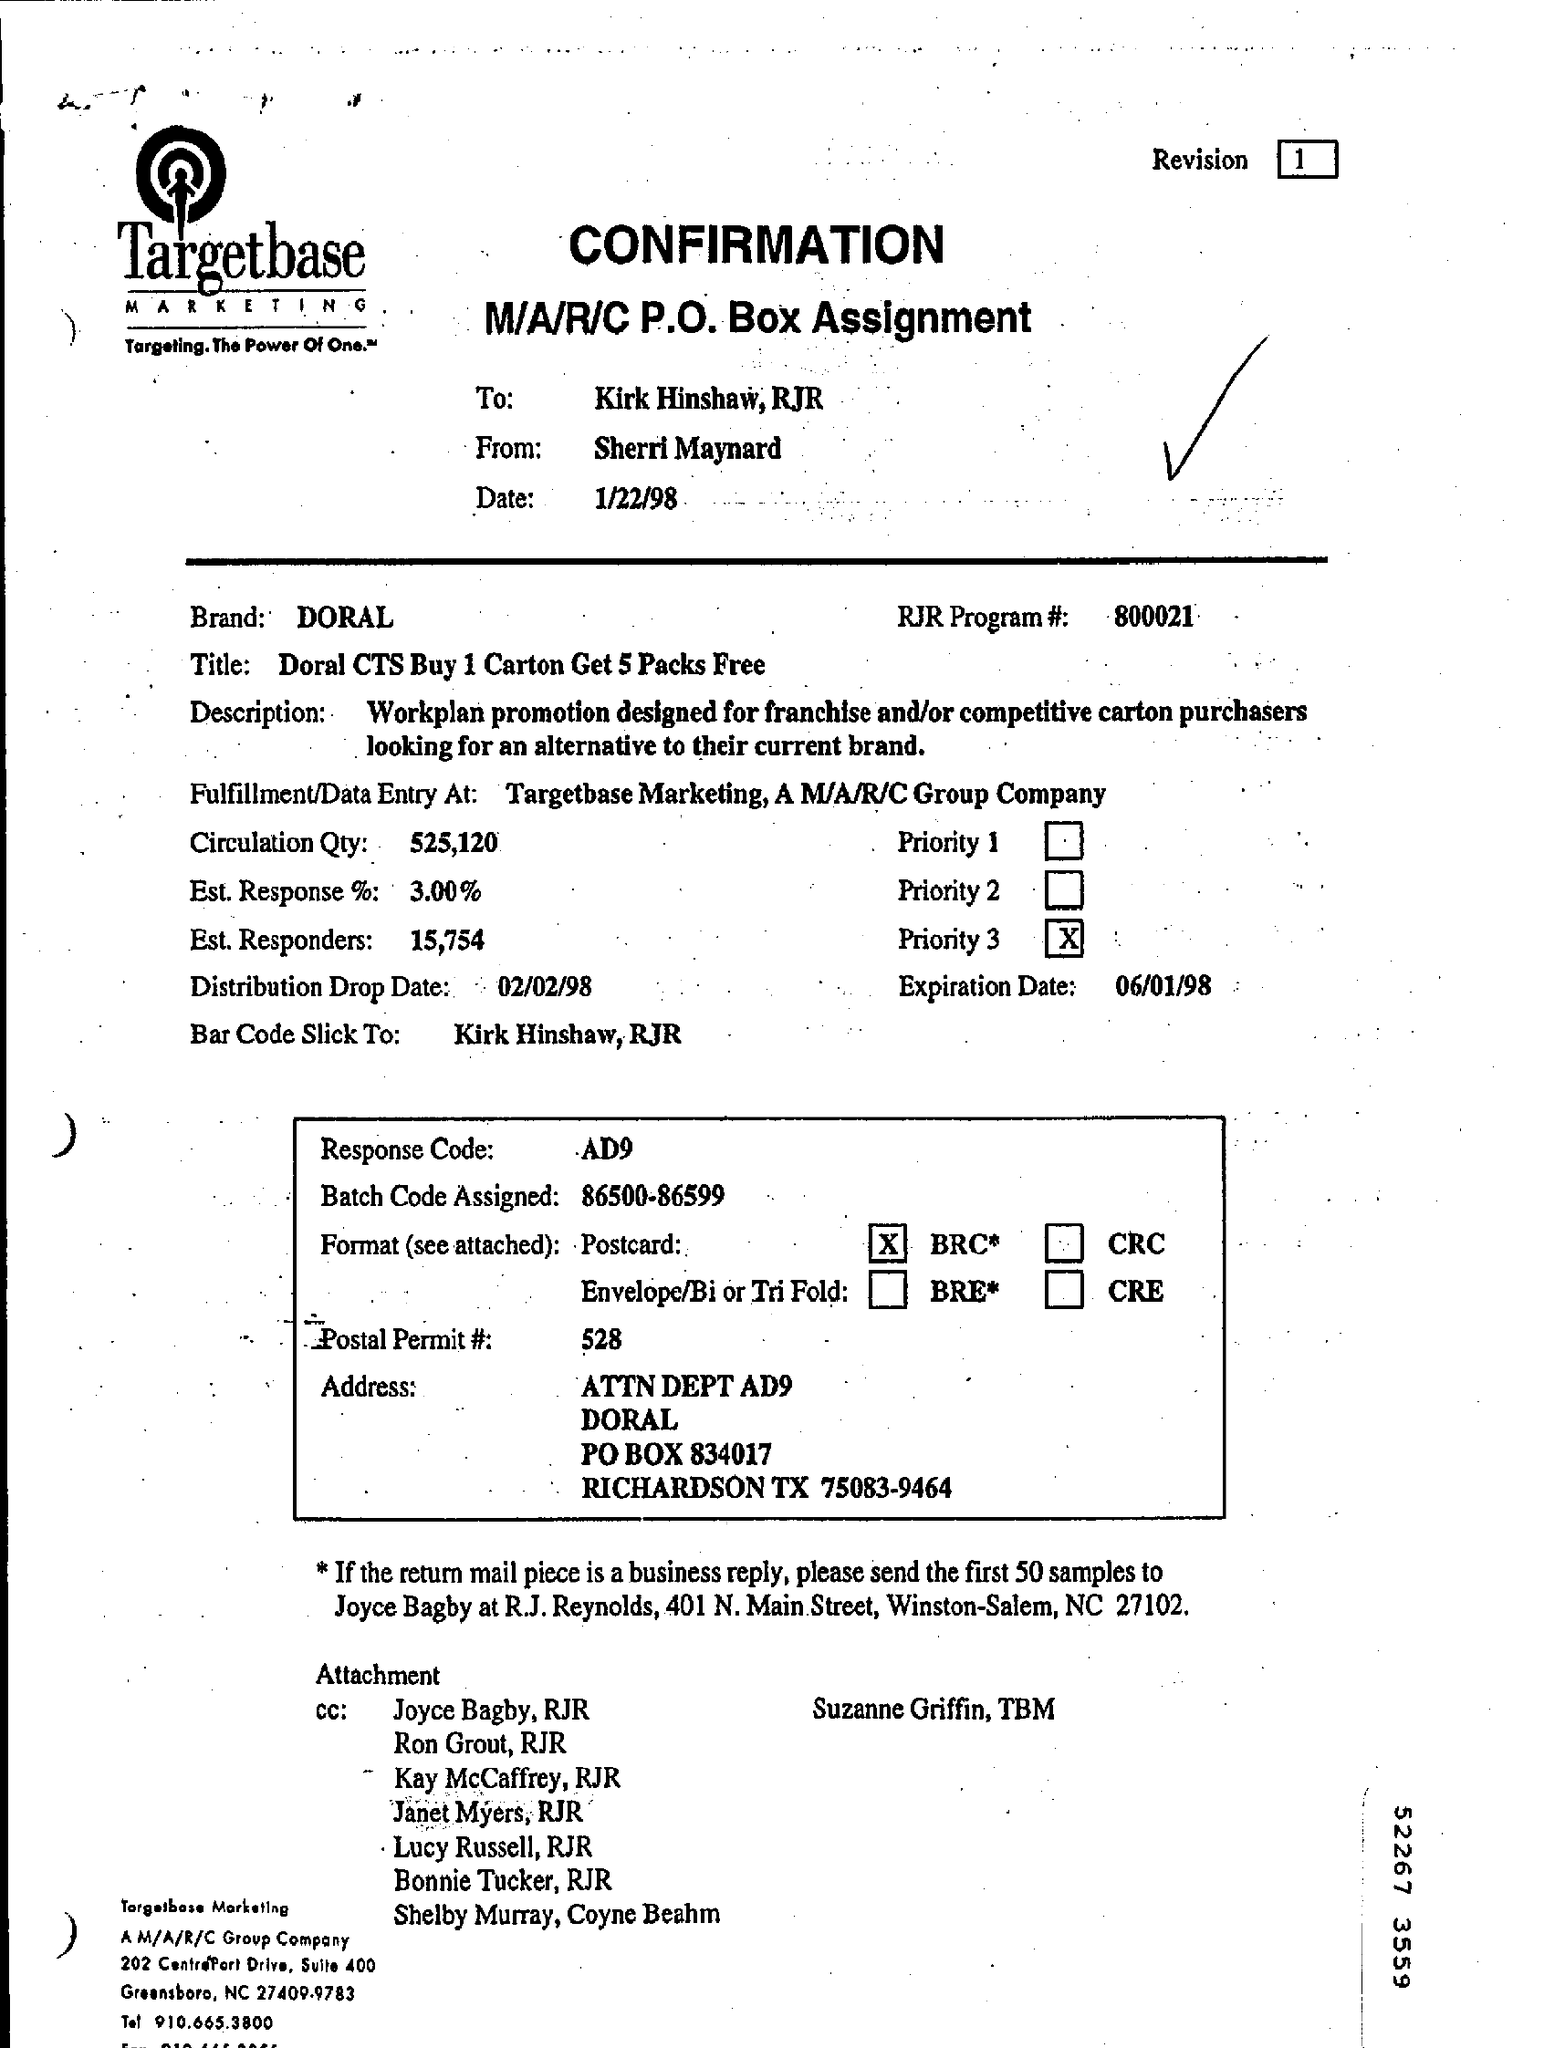To whom is the confirmation addressed?
Your response must be concise. Kirk Hinshaw, RJR. From whom is the confirmation?
Provide a short and direct response. SHERRI MAYNARD. When is the document dated?
Offer a terse response. 1/22/98. Which brand is mentioned?
Offer a terse response. DORAL. What is the RJR Program number?
Offer a terse response. 800021. What is the batch code assigned?
Provide a succinct answer. 86500-86599. What is the estimated response %?
Your response must be concise. 3.00%. 